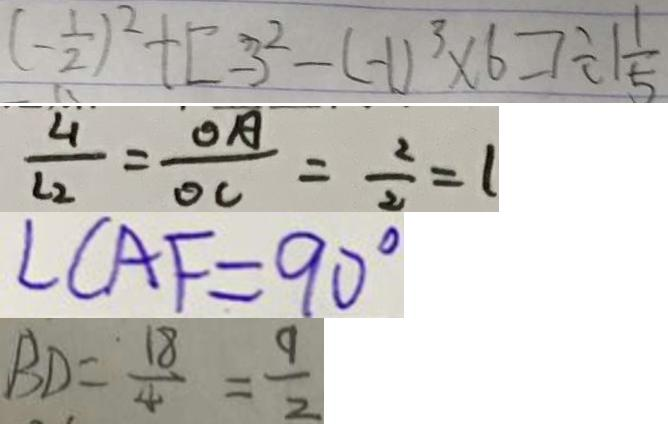Convert formula to latex. <formula><loc_0><loc_0><loc_500><loc_500>( - \frac { 1 } { 2 } ) ^ { 2 } + [ - 3 ^ { 2 } - ( - 1 ) ^ { 3 } \times 6 ] \div 1 \frac { 1 } { 5 } 
 \frac { 4 } { l _ { 2 } } = \frac { O A } { O C } = \frac { 2 } { 2 } = 1 
 \angle C A F = 9 0 ^ { \circ } 
 B D = \frac { 1 8 } { 4 } = \frac { 9 } { 2 }</formula> 